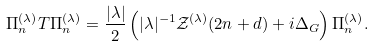<formula> <loc_0><loc_0><loc_500><loc_500>\Pi _ { n } ^ { ( \lambda ) } T \Pi _ { n } ^ { ( \lambda ) } = \frac { | \lambda | } 2 \left ( | \lambda | ^ { - 1 } { \mathcal { Z } } ^ { ( \lambda ) } ( 2 n + d ) + i \Delta _ { G } \right ) \Pi _ { n } ^ { ( \lambda ) } .</formula> 